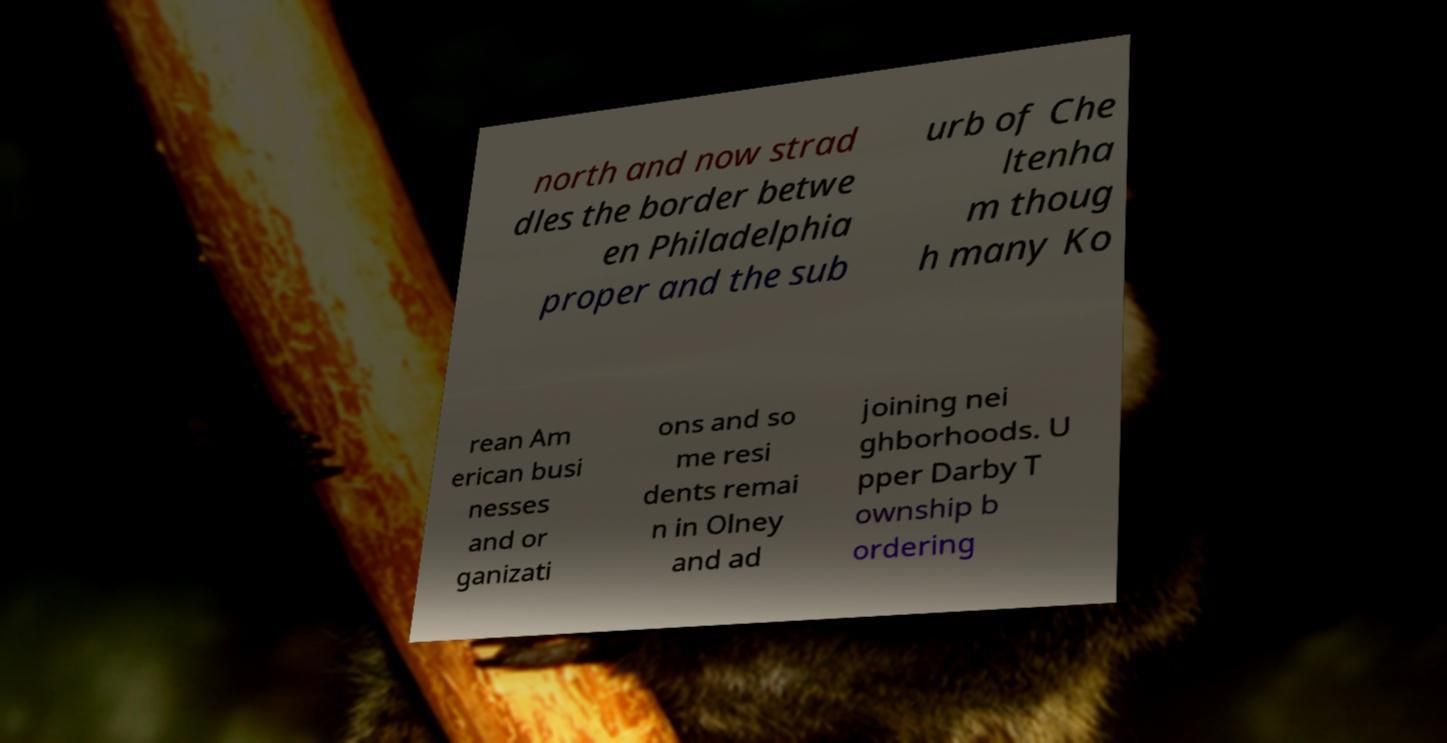I need the written content from this picture converted into text. Can you do that? north and now strad dles the border betwe en Philadelphia proper and the sub urb of Che ltenha m thoug h many Ko rean Am erican busi nesses and or ganizati ons and so me resi dents remai n in Olney and ad joining nei ghborhoods. U pper Darby T ownship b ordering 